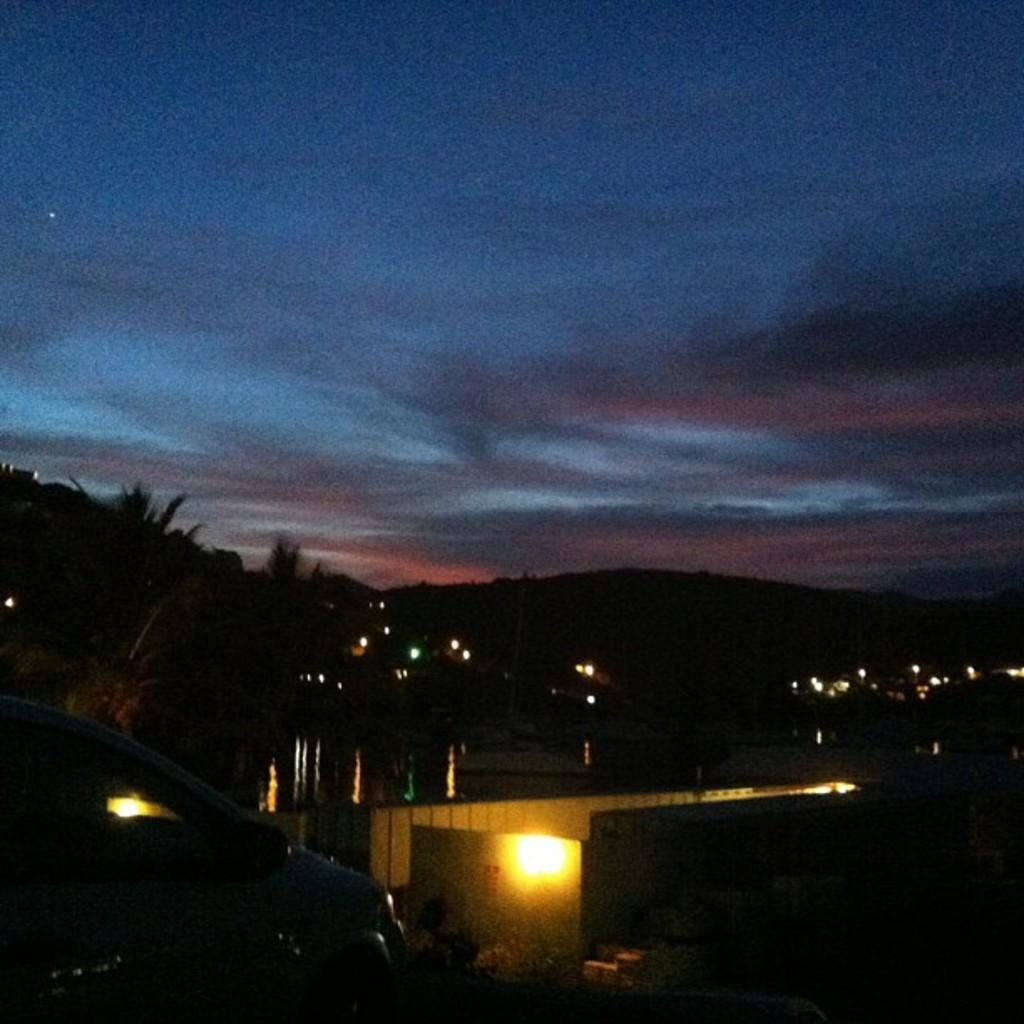What type of vegetation can be seen in the image? There are trees in the image. What mode of transportation is visible in the image? There is a car in the image. What type of illumination is present in the image? There is a light in the image. What color is the sky in the image? The sky is blue in color. What type of agreement is being signed in the image? There is no indication of an agreement or any signing activity in the image. Which direction is the car facing in the image? The direction the car is facing cannot be determined from the image. 